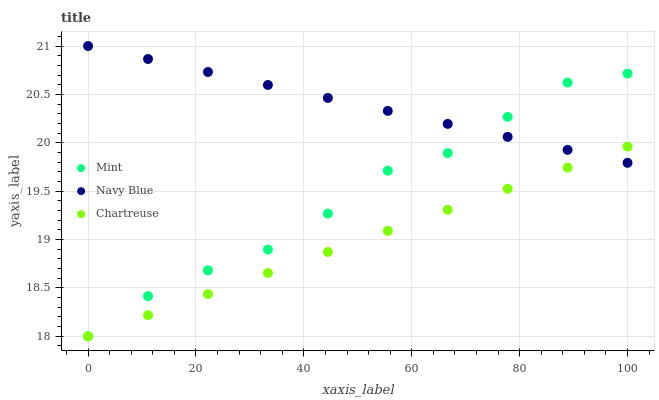Does Chartreuse have the minimum area under the curve?
Answer yes or no. Yes. Does Navy Blue have the maximum area under the curve?
Answer yes or no. Yes. Does Mint have the minimum area under the curve?
Answer yes or no. No. Does Mint have the maximum area under the curve?
Answer yes or no. No. Is Chartreuse the smoothest?
Answer yes or no. Yes. Is Mint the roughest?
Answer yes or no. Yes. Is Mint the smoothest?
Answer yes or no. No. Is Chartreuse the roughest?
Answer yes or no. No. Does Chartreuse have the lowest value?
Answer yes or no. Yes. Does Navy Blue have the highest value?
Answer yes or no. Yes. Does Mint have the highest value?
Answer yes or no. No. Does Mint intersect Navy Blue?
Answer yes or no. Yes. Is Mint less than Navy Blue?
Answer yes or no. No. Is Mint greater than Navy Blue?
Answer yes or no. No. 